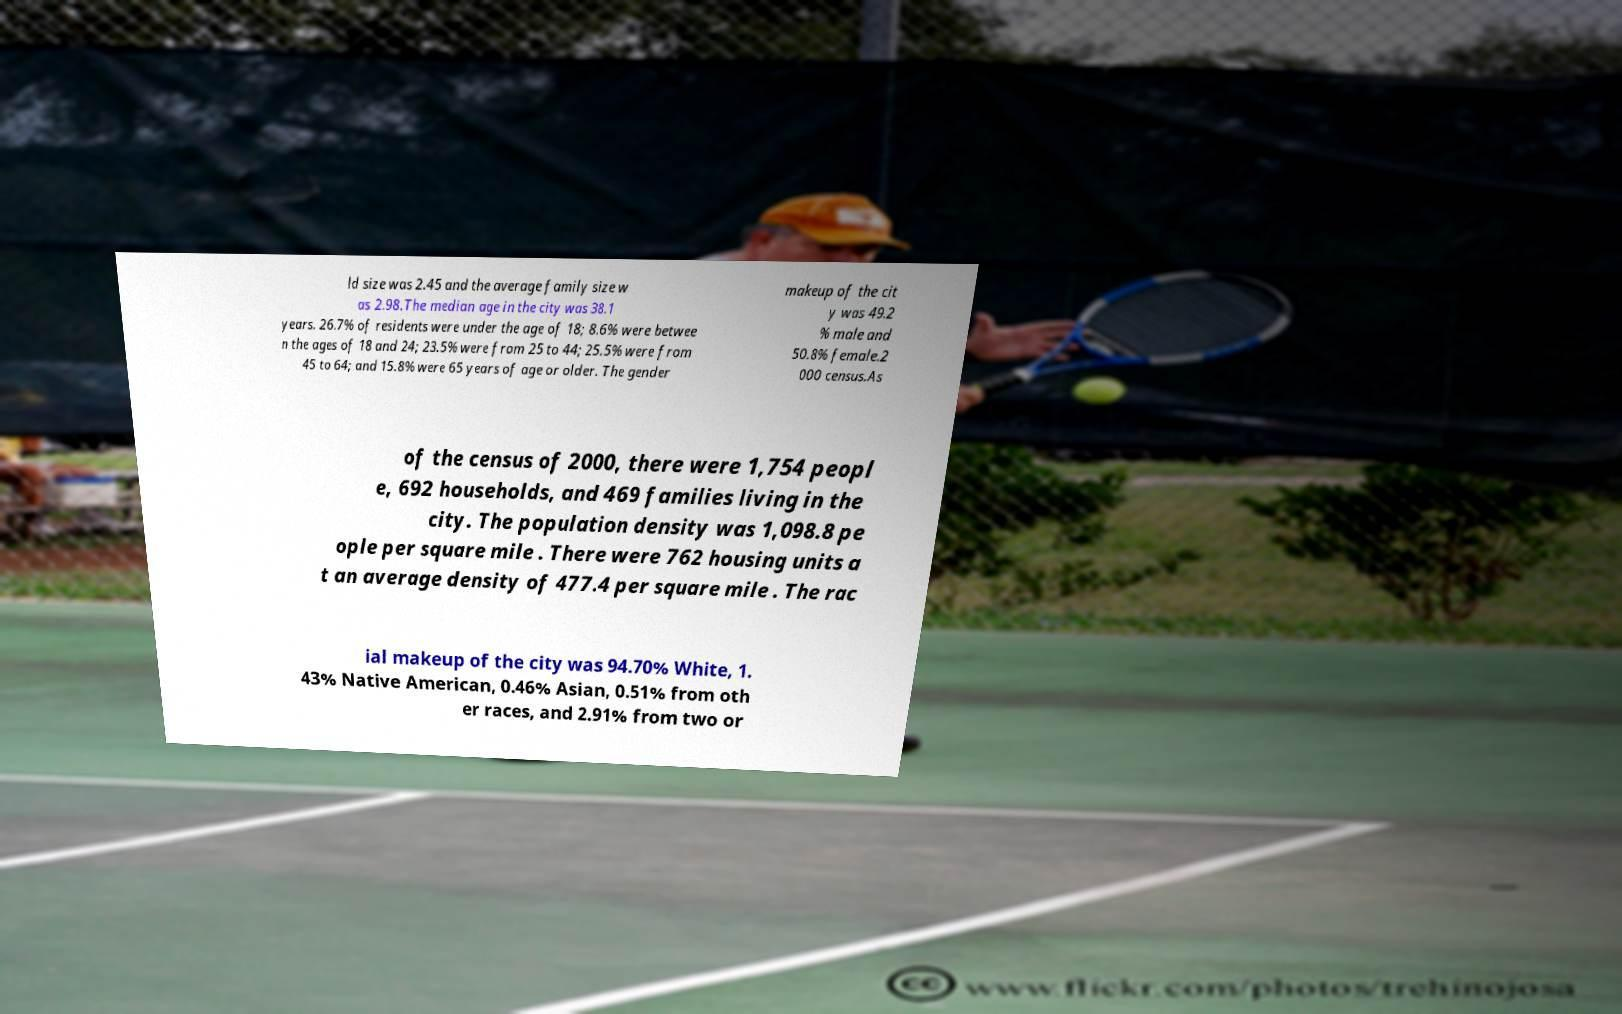What messages or text are displayed in this image? I need them in a readable, typed format. ld size was 2.45 and the average family size w as 2.98.The median age in the city was 38.1 years. 26.7% of residents were under the age of 18; 8.6% were betwee n the ages of 18 and 24; 23.5% were from 25 to 44; 25.5% were from 45 to 64; and 15.8% were 65 years of age or older. The gender makeup of the cit y was 49.2 % male and 50.8% female.2 000 census.As of the census of 2000, there were 1,754 peopl e, 692 households, and 469 families living in the city. The population density was 1,098.8 pe ople per square mile . There were 762 housing units a t an average density of 477.4 per square mile . The rac ial makeup of the city was 94.70% White, 1. 43% Native American, 0.46% Asian, 0.51% from oth er races, and 2.91% from two or 